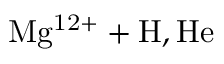<formula> <loc_0><loc_0><loc_500><loc_500>M g ^ { 1 2 + } + H , H e</formula> 